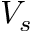Convert formula to latex. <formula><loc_0><loc_0><loc_500><loc_500>V _ { s }</formula> 